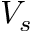Convert formula to latex. <formula><loc_0><loc_0><loc_500><loc_500>V _ { s }</formula> 